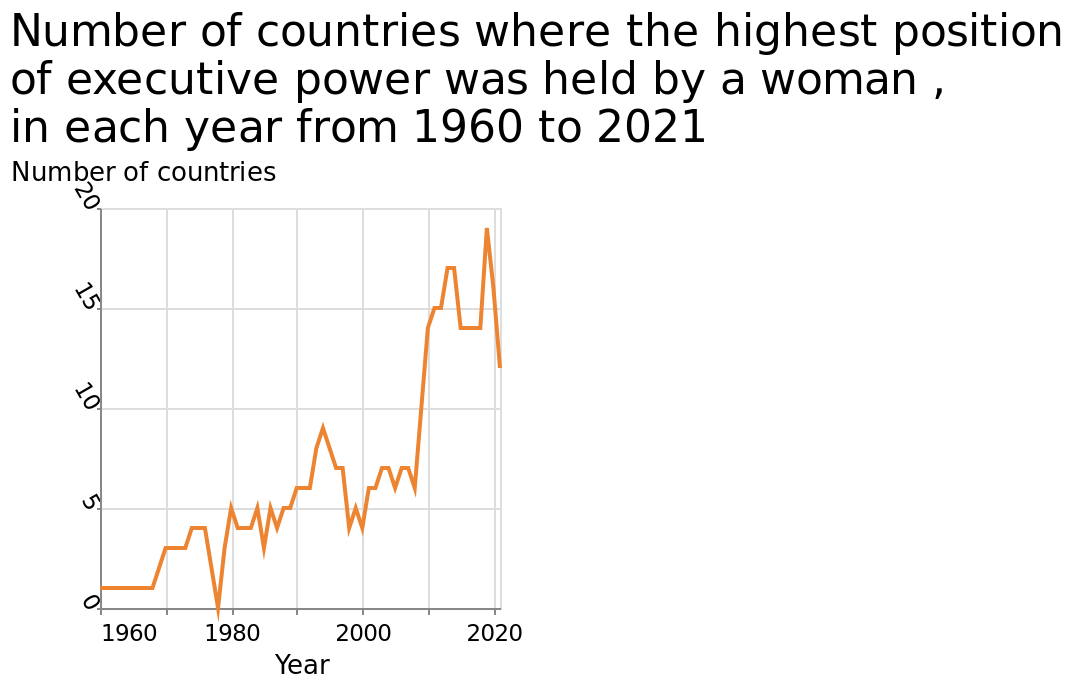<image>
Are the countries with increasing numbers specified? No, the countries are not specified. Have there been any reductions in numbers periodically?  Yes, there have been some reductions in numbers periodically. please enumerates aspects of the construction of the chart This line plot is called Number of countries where the highest position of executive power was held by a woman , in each year from 1960 to 2021. The y-axis measures Number of countries along linear scale with a minimum of 0 and a maximum of 20 while the x-axis measures Year using linear scale of range 1960 to 2020. 